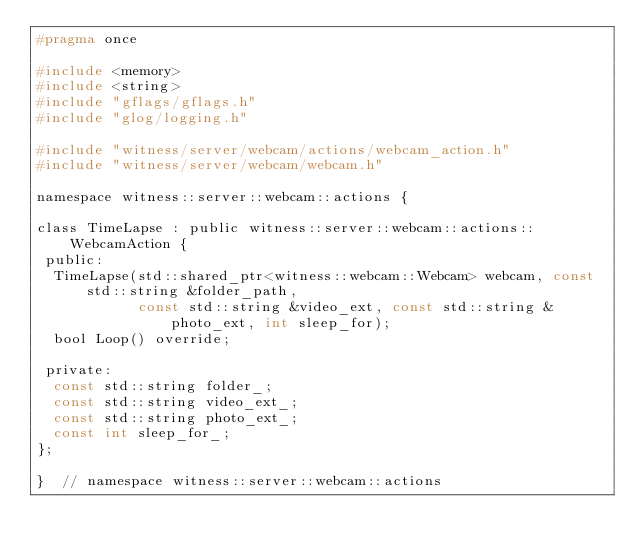<code> <loc_0><loc_0><loc_500><loc_500><_C_>#pragma once

#include <memory>
#include <string>
#include "gflags/gflags.h"
#include "glog/logging.h"

#include "witness/server/webcam/actions/webcam_action.h"
#include "witness/server/webcam/webcam.h"

namespace witness::server::webcam::actions {

class TimeLapse : public witness::server::webcam::actions::WebcamAction {
 public:
  TimeLapse(std::shared_ptr<witness::webcam::Webcam> webcam, const std::string &folder_path,
            const std::string &video_ext, const std::string &photo_ext, int sleep_for);
  bool Loop() override;

 private:
  const std::string folder_;
  const std::string video_ext_;
  const std::string photo_ext_;
  const int sleep_for_;
};

}  // namespace witness::server::webcam::actions
</code> 